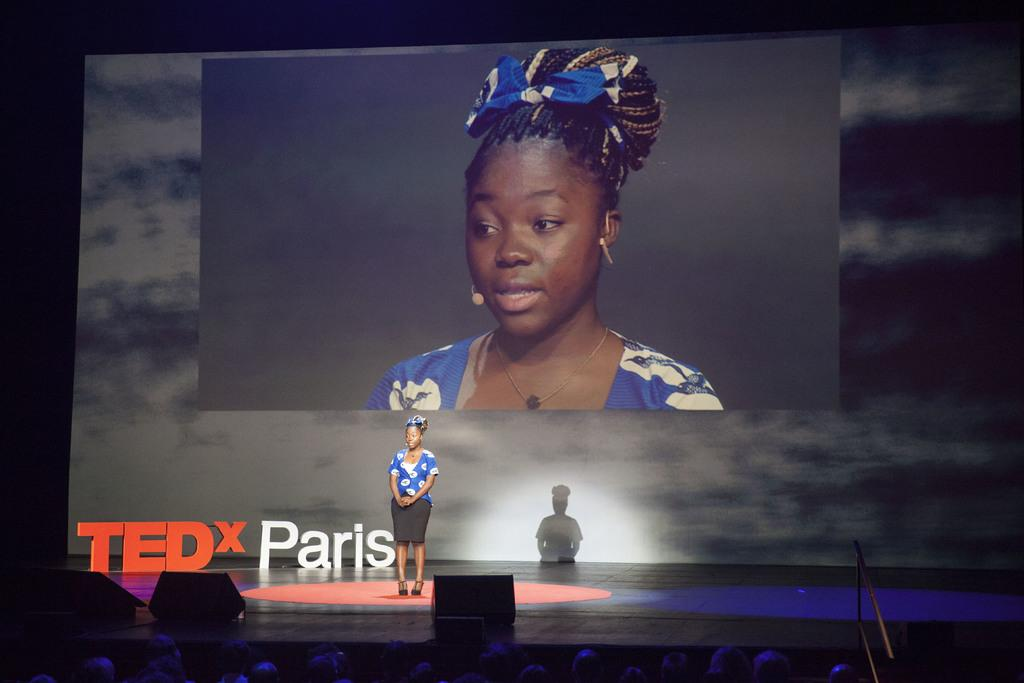Who is the main subject in the image? There is a lady standing in the center of the image. What is happening at the bottom of the image? There is a crowd at the bottom of the image. What objects are used for amplifying sound in the image? There are speakers visible in the image. What can be seen in the background of the image? There is a screen in the background of the image. How many passengers are visible in the image? There is no reference to passengers in the image; it features a lady, a crowd, speakers, and a screen. 